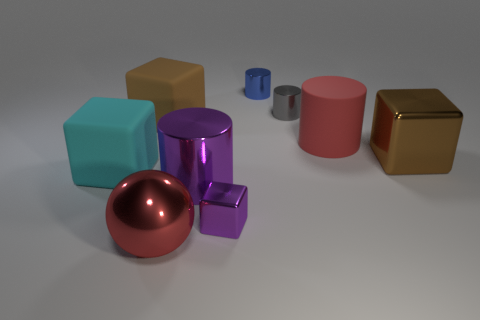Subtract 1 cylinders. How many cylinders are left? 3 Add 1 large brown matte objects. How many objects exist? 10 Subtract all balls. How many objects are left? 8 Subtract 0 yellow cylinders. How many objects are left? 9 Subtract all large red shiny cylinders. Subtract all metal blocks. How many objects are left? 7 Add 7 large metal cylinders. How many large metal cylinders are left? 8 Add 7 red metal things. How many red metal things exist? 8 